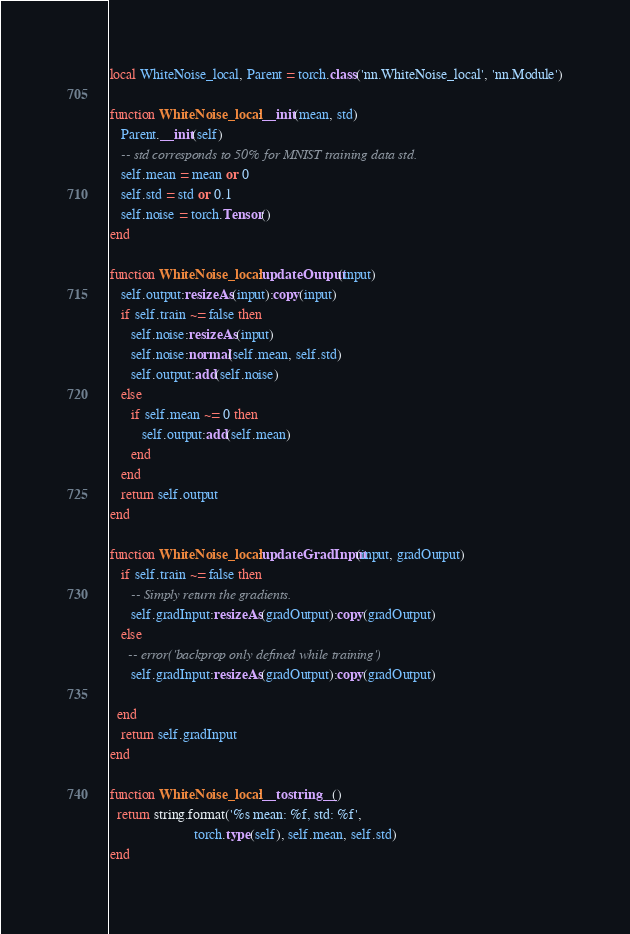Convert code to text. <code><loc_0><loc_0><loc_500><loc_500><_Lua_>local WhiteNoise_local, Parent = torch.class('nn.WhiteNoise_local', 'nn.Module')

function WhiteNoise_local:__init(mean, std)
   Parent.__init(self)
   -- std corresponds to 50% for MNIST training data std.
   self.mean = mean or 0
   self.std = std or 0.1
   self.noise = torch.Tensor()
end

function WhiteNoise_local:updateOutput(input)
   self.output:resizeAs(input):copy(input)
   if self.train ~= false then
      self.noise:resizeAs(input)
      self.noise:normal(self.mean, self.std)
      self.output:add(self.noise)
   else
      if self.mean ~= 0 then
         self.output:add(self.mean)
      end
   end
   return self.output
end

function WhiteNoise_local:updateGradInput(input, gradOutput)
   if self.train ~= false then
      -- Simply return the gradients.
      self.gradInput:resizeAs(gradOutput):copy(gradOutput)
   else
     -- error('backprop only defined while training')
      self.gradInput:resizeAs(gradOutput):copy(gradOutput)

  end
   return self.gradInput
end

function WhiteNoise_local:__tostring__()
  return string.format('%s mean: %f, std: %f', 
                        torch.type(self), self.mean, self.std)
end
</code> 